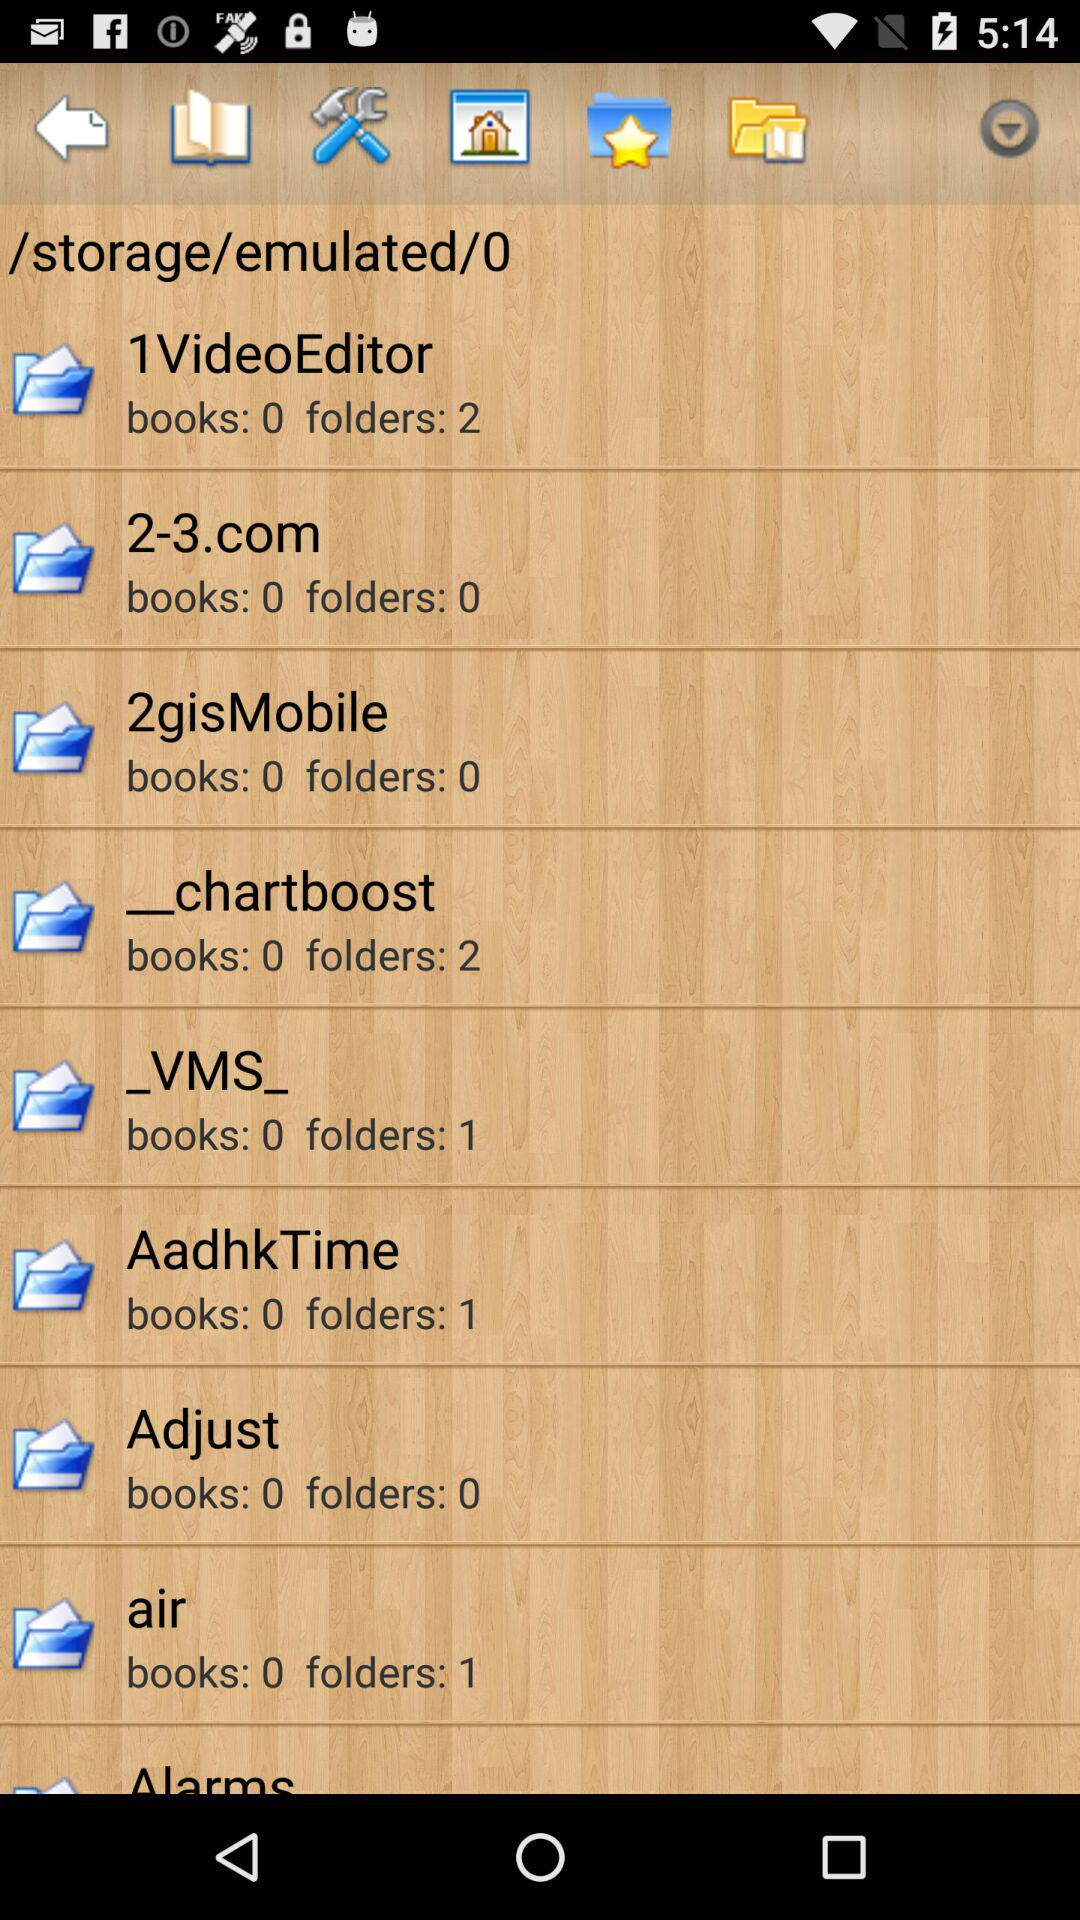How many folders are there in the "_VMS_" folder? There is 1 folder in the "_VMS_" folder. 